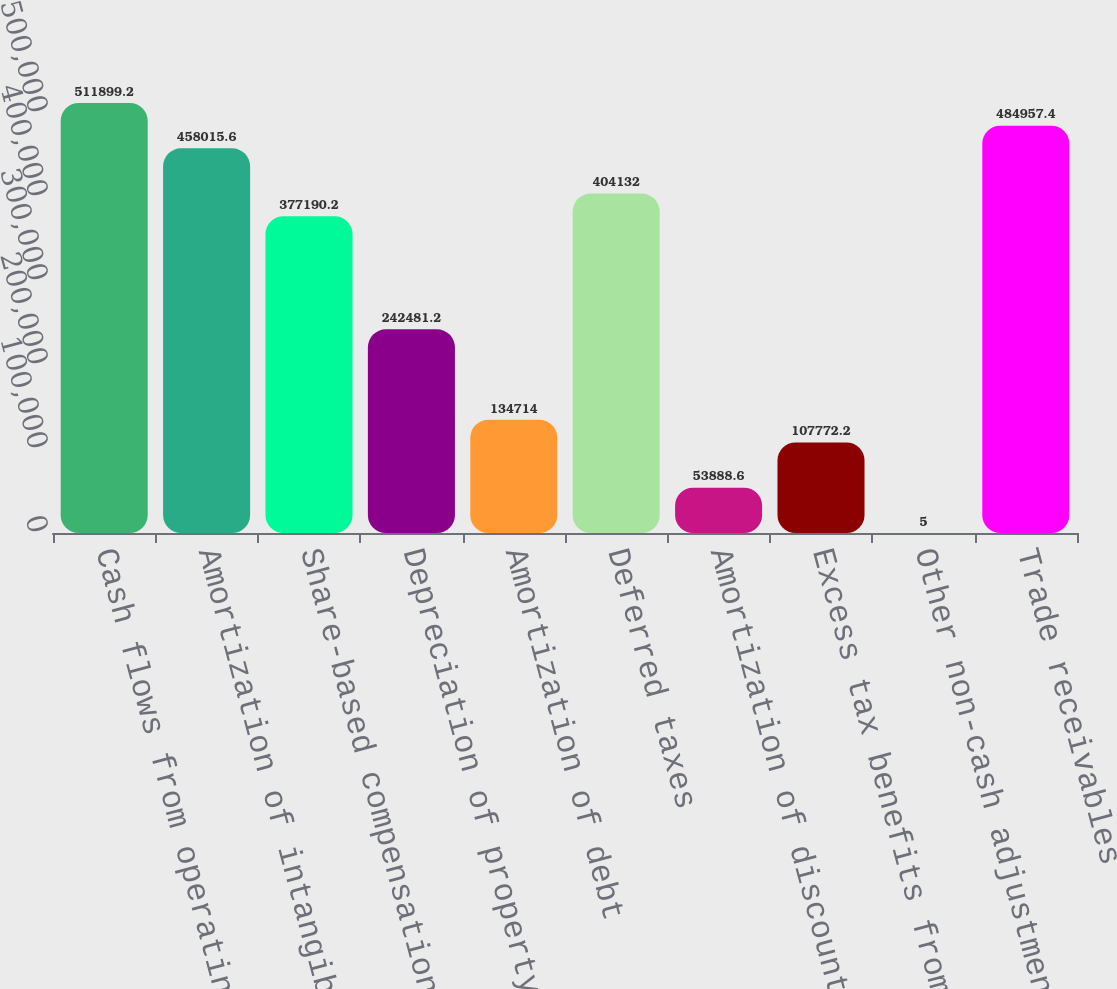Convert chart to OTSL. <chart><loc_0><loc_0><loc_500><loc_500><bar_chart><fcel>Cash flows from operating<fcel>Amortization of intangible<fcel>Share-based compensation<fcel>Depreciation of property<fcel>Amortization of debt<fcel>Deferred taxes<fcel>Amortization of discount on<fcel>Excess tax benefits from<fcel>Other non-cash adjustments<fcel>Trade receivables<nl><fcel>511899<fcel>458016<fcel>377190<fcel>242481<fcel>134714<fcel>404132<fcel>53888.6<fcel>107772<fcel>5<fcel>484957<nl></chart> 